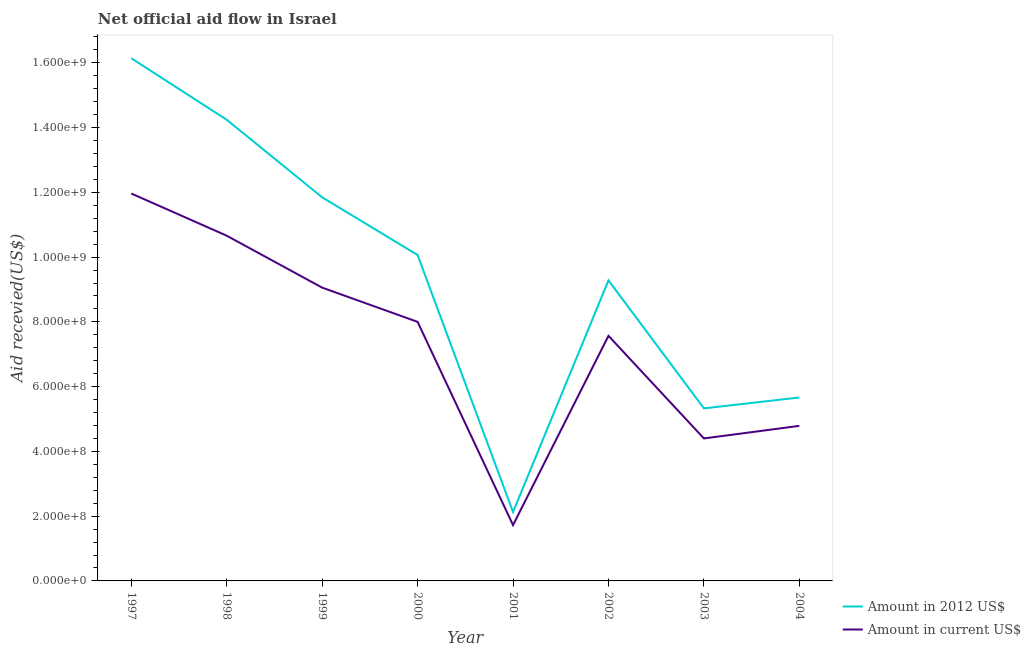Is the number of lines equal to the number of legend labels?
Make the answer very short. Yes. What is the amount of aid received(expressed in 2012 us$) in 1997?
Your answer should be compact. 1.61e+09. Across all years, what is the maximum amount of aid received(expressed in 2012 us$)?
Keep it short and to the point. 1.61e+09. Across all years, what is the minimum amount of aid received(expressed in us$)?
Keep it short and to the point. 1.72e+08. In which year was the amount of aid received(expressed in us$) minimum?
Provide a succinct answer. 2001. What is the total amount of aid received(expressed in 2012 us$) in the graph?
Your response must be concise. 7.47e+09. What is the difference between the amount of aid received(expressed in us$) in 1999 and that in 2002?
Offer a terse response. 1.49e+08. What is the difference between the amount of aid received(expressed in us$) in 2003 and the amount of aid received(expressed in 2012 us$) in 2000?
Offer a terse response. -5.66e+08. What is the average amount of aid received(expressed in 2012 us$) per year?
Offer a very short reply. 9.34e+08. In the year 2004, what is the difference between the amount of aid received(expressed in 2012 us$) and amount of aid received(expressed in us$)?
Provide a short and direct response. 8.76e+07. What is the ratio of the amount of aid received(expressed in us$) in 2001 to that in 2002?
Keep it short and to the point. 0.23. Is the amount of aid received(expressed in us$) in 2001 less than that in 2004?
Offer a terse response. Yes. Is the difference between the amount of aid received(expressed in 2012 us$) in 1998 and 2003 greater than the difference between the amount of aid received(expressed in us$) in 1998 and 2003?
Provide a short and direct response. Yes. What is the difference between the highest and the second highest amount of aid received(expressed in 2012 us$)?
Provide a succinct answer. 1.90e+08. What is the difference between the highest and the lowest amount of aid received(expressed in 2012 us$)?
Provide a succinct answer. 1.40e+09. Is the sum of the amount of aid received(expressed in 2012 us$) in 2001 and 2004 greater than the maximum amount of aid received(expressed in us$) across all years?
Provide a short and direct response. No. Is the amount of aid received(expressed in 2012 us$) strictly less than the amount of aid received(expressed in us$) over the years?
Provide a short and direct response. No. How many lines are there?
Keep it short and to the point. 2. How many years are there in the graph?
Keep it short and to the point. 8. What is the difference between two consecutive major ticks on the Y-axis?
Your answer should be compact. 2.00e+08. Are the values on the major ticks of Y-axis written in scientific E-notation?
Offer a very short reply. Yes. Does the graph contain any zero values?
Make the answer very short. No. Does the graph contain grids?
Your answer should be very brief. No. How many legend labels are there?
Give a very brief answer. 2. What is the title of the graph?
Ensure brevity in your answer.  Net official aid flow in Israel. What is the label or title of the X-axis?
Your answer should be very brief. Year. What is the label or title of the Y-axis?
Your answer should be very brief. Aid recevied(US$). What is the Aid recevied(US$) in Amount in 2012 US$ in 1997?
Your answer should be compact. 1.61e+09. What is the Aid recevied(US$) in Amount in current US$ in 1997?
Keep it short and to the point. 1.20e+09. What is the Aid recevied(US$) of Amount in 2012 US$ in 1998?
Provide a short and direct response. 1.42e+09. What is the Aid recevied(US$) of Amount in current US$ in 1998?
Ensure brevity in your answer.  1.07e+09. What is the Aid recevied(US$) of Amount in 2012 US$ in 1999?
Make the answer very short. 1.18e+09. What is the Aid recevied(US$) in Amount in current US$ in 1999?
Your answer should be compact. 9.06e+08. What is the Aid recevied(US$) in Amount in 2012 US$ in 2000?
Offer a terse response. 1.01e+09. What is the Aid recevied(US$) in Amount in current US$ in 2000?
Provide a succinct answer. 8.00e+08. What is the Aid recevied(US$) in Amount in 2012 US$ in 2001?
Provide a succinct answer. 2.13e+08. What is the Aid recevied(US$) in Amount in current US$ in 2001?
Provide a short and direct response. 1.72e+08. What is the Aid recevied(US$) in Amount in 2012 US$ in 2002?
Ensure brevity in your answer.  9.28e+08. What is the Aid recevied(US$) of Amount in current US$ in 2002?
Keep it short and to the point. 7.57e+08. What is the Aid recevied(US$) in Amount in 2012 US$ in 2003?
Offer a terse response. 5.33e+08. What is the Aid recevied(US$) of Amount in current US$ in 2003?
Offer a terse response. 4.40e+08. What is the Aid recevied(US$) in Amount in 2012 US$ in 2004?
Provide a short and direct response. 5.66e+08. What is the Aid recevied(US$) in Amount in current US$ in 2004?
Your answer should be very brief. 4.79e+08. Across all years, what is the maximum Aid recevied(US$) of Amount in 2012 US$?
Your response must be concise. 1.61e+09. Across all years, what is the maximum Aid recevied(US$) of Amount in current US$?
Offer a very short reply. 1.20e+09. Across all years, what is the minimum Aid recevied(US$) of Amount in 2012 US$?
Provide a succinct answer. 2.13e+08. Across all years, what is the minimum Aid recevied(US$) in Amount in current US$?
Your answer should be very brief. 1.72e+08. What is the total Aid recevied(US$) in Amount in 2012 US$ in the graph?
Your answer should be very brief. 7.47e+09. What is the total Aid recevied(US$) of Amount in current US$ in the graph?
Your answer should be very brief. 5.82e+09. What is the difference between the Aid recevied(US$) of Amount in 2012 US$ in 1997 and that in 1998?
Your answer should be very brief. 1.90e+08. What is the difference between the Aid recevied(US$) of Amount in current US$ in 1997 and that in 1998?
Your answer should be very brief. 1.30e+08. What is the difference between the Aid recevied(US$) in Amount in 2012 US$ in 1997 and that in 1999?
Your answer should be compact. 4.29e+08. What is the difference between the Aid recevied(US$) in Amount in current US$ in 1997 and that in 1999?
Your response must be concise. 2.91e+08. What is the difference between the Aid recevied(US$) of Amount in 2012 US$ in 1997 and that in 2000?
Your answer should be very brief. 6.08e+08. What is the difference between the Aid recevied(US$) in Amount in current US$ in 1997 and that in 2000?
Your answer should be compact. 3.96e+08. What is the difference between the Aid recevied(US$) of Amount in 2012 US$ in 1997 and that in 2001?
Provide a short and direct response. 1.40e+09. What is the difference between the Aid recevied(US$) of Amount in current US$ in 1997 and that in 2001?
Keep it short and to the point. 1.02e+09. What is the difference between the Aid recevied(US$) in Amount in 2012 US$ in 1997 and that in 2002?
Make the answer very short. 6.86e+08. What is the difference between the Aid recevied(US$) of Amount in current US$ in 1997 and that in 2002?
Provide a short and direct response. 4.39e+08. What is the difference between the Aid recevied(US$) of Amount in 2012 US$ in 1997 and that in 2003?
Provide a succinct answer. 1.08e+09. What is the difference between the Aid recevied(US$) of Amount in current US$ in 1997 and that in 2003?
Your response must be concise. 7.56e+08. What is the difference between the Aid recevied(US$) of Amount in 2012 US$ in 1997 and that in 2004?
Give a very brief answer. 1.05e+09. What is the difference between the Aid recevied(US$) in Amount in current US$ in 1997 and that in 2004?
Offer a very short reply. 7.18e+08. What is the difference between the Aid recevied(US$) in Amount in 2012 US$ in 1998 and that in 1999?
Provide a succinct answer. 2.39e+08. What is the difference between the Aid recevied(US$) of Amount in current US$ in 1998 and that in 1999?
Provide a short and direct response. 1.60e+08. What is the difference between the Aid recevied(US$) of Amount in 2012 US$ in 1998 and that in 2000?
Your response must be concise. 4.18e+08. What is the difference between the Aid recevied(US$) of Amount in current US$ in 1998 and that in 2000?
Ensure brevity in your answer.  2.66e+08. What is the difference between the Aid recevied(US$) in Amount in 2012 US$ in 1998 and that in 2001?
Keep it short and to the point. 1.21e+09. What is the difference between the Aid recevied(US$) in Amount in current US$ in 1998 and that in 2001?
Make the answer very short. 8.94e+08. What is the difference between the Aid recevied(US$) in Amount in 2012 US$ in 1998 and that in 2002?
Offer a terse response. 4.96e+08. What is the difference between the Aid recevied(US$) in Amount in current US$ in 1998 and that in 2002?
Your answer should be compact. 3.09e+08. What is the difference between the Aid recevied(US$) of Amount in 2012 US$ in 1998 and that in 2003?
Keep it short and to the point. 8.91e+08. What is the difference between the Aid recevied(US$) in Amount in current US$ in 1998 and that in 2003?
Offer a very short reply. 6.26e+08. What is the difference between the Aid recevied(US$) in Amount in 2012 US$ in 1998 and that in 2004?
Your response must be concise. 8.58e+08. What is the difference between the Aid recevied(US$) of Amount in current US$ in 1998 and that in 2004?
Your answer should be very brief. 5.87e+08. What is the difference between the Aid recevied(US$) of Amount in 2012 US$ in 1999 and that in 2000?
Keep it short and to the point. 1.78e+08. What is the difference between the Aid recevied(US$) in Amount in current US$ in 1999 and that in 2000?
Ensure brevity in your answer.  1.06e+08. What is the difference between the Aid recevied(US$) of Amount in 2012 US$ in 1999 and that in 2001?
Ensure brevity in your answer.  9.72e+08. What is the difference between the Aid recevied(US$) of Amount in current US$ in 1999 and that in 2001?
Provide a succinct answer. 7.33e+08. What is the difference between the Aid recevied(US$) in Amount in 2012 US$ in 1999 and that in 2002?
Provide a succinct answer. 2.57e+08. What is the difference between the Aid recevied(US$) of Amount in current US$ in 1999 and that in 2002?
Keep it short and to the point. 1.49e+08. What is the difference between the Aid recevied(US$) in Amount in 2012 US$ in 1999 and that in 2003?
Provide a succinct answer. 6.52e+08. What is the difference between the Aid recevied(US$) in Amount in current US$ in 1999 and that in 2003?
Provide a short and direct response. 4.66e+08. What is the difference between the Aid recevied(US$) in Amount in 2012 US$ in 1999 and that in 2004?
Provide a short and direct response. 6.18e+08. What is the difference between the Aid recevied(US$) of Amount in current US$ in 1999 and that in 2004?
Make the answer very short. 4.27e+08. What is the difference between the Aid recevied(US$) of Amount in 2012 US$ in 2000 and that in 2001?
Ensure brevity in your answer.  7.94e+08. What is the difference between the Aid recevied(US$) of Amount in current US$ in 2000 and that in 2001?
Offer a terse response. 6.28e+08. What is the difference between the Aid recevied(US$) of Amount in 2012 US$ in 2000 and that in 2002?
Offer a terse response. 7.83e+07. What is the difference between the Aid recevied(US$) of Amount in current US$ in 2000 and that in 2002?
Offer a very short reply. 4.31e+07. What is the difference between the Aid recevied(US$) of Amount in 2012 US$ in 2000 and that in 2003?
Give a very brief answer. 4.74e+08. What is the difference between the Aid recevied(US$) in Amount in current US$ in 2000 and that in 2003?
Provide a short and direct response. 3.60e+08. What is the difference between the Aid recevied(US$) in Amount in 2012 US$ in 2000 and that in 2004?
Offer a terse response. 4.40e+08. What is the difference between the Aid recevied(US$) of Amount in current US$ in 2000 and that in 2004?
Offer a terse response. 3.21e+08. What is the difference between the Aid recevied(US$) of Amount in 2012 US$ in 2001 and that in 2002?
Provide a short and direct response. -7.15e+08. What is the difference between the Aid recevied(US$) of Amount in current US$ in 2001 and that in 2002?
Offer a very short reply. -5.85e+08. What is the difference between the Aid recevied(US$) in Amount in 2012 US$ in 2001 and that in 2003?
Offer a very short reply. -3.20e+08. What is the difference between the Aid recevied(US$) in Amount in current US$ in 2001 and that in 2003?
Provide a short and direct response. -2.68e+08. What is the difference between the Aid recevied(US$) in Amount in 2012 US$ in 2001 and that in 2004?
Your answer should be compact. -3.54e+08. What is the difference between the Aid recevied(US$) in Amount in current US$ in 2001 and that in 2004?
Offer a terse response. -3.06e+08. What is the difference between the Aid recevied(US$) in Amount in 2012 US$ in 2002 and that in 2003?
Make the answer very short. 3.95e+08. What is the difference between the Aid recevied(US$) in Amount in current US$ in 2002 and that in 2003?
Your response must be concise. 3.17e+08. What is the difference between the Aid recevied(US$) in Amount in 2012 US$ in 2002 and that in 2004?
Keep it short and to the point. 3.62e+08. What is the difference between the Aid recevied(US$) in Amount in current US$ in 2002 and that in 2004?
Give a very brief answer. 2.78e+08. What is the difference between the Aid recevied(US$) in Amount in 2012 US$ in 2003 and that in 2004?
Make the answer very short. -3.36e+07. What is the difference between the Aid recevied(US$) in Amount in current US$ in 2003 and that in 2004?
Keep it short and to the point. -3.89e+07. What is the difference between the Aid recevied(US$) of Amount in 2012 US$ in 1997 and the Aid recevied(US$) of Amount in current US$ in 1998?
Provide a succinct answer. 5.48e+08. What is the difference between the Aid recevied(US$) of Amount in 2012 US$ in 1997 and the Aid recevied(US$) of Amount in current US$ in 1999?
Provide a succinct answer. 7.08e+08. What is the difference between the Aid recevied(US$) of Amount in 2012 US$ in 1997 and the Aid recevied(US$) of Amount in current US$ in 2000?
Provide a succinct answer. 8.14e+08. What is the difference between the Aid recevied(US$) of Amount in 2012 US$ in 1997 and the Aid recevied(US$) of Amount in current US$ in 2001?
Make the answer very short. 1.44e+09. What is the difference between the Aid recevied(US$) of Amount in 2012 US$ in 1997 and the Aid recevied(US$) of Amount in current US$ in 2002?
Your answer should be compact. 8.57e+08. What is the difference between the Aid recevied(US$) in Amount in 2012 US$ in 1997 and the Aid recevied(US$) in Amount in current US$ in 2003?
Offer a terse response. 1.17e+09. What is the difference between the Aid recevied(US$) in Amount in 2012 US$ in 1997 and the Aid recevied(US$) in Amount in current US$ in 2004?
Keep it short and to the point. 1.14e+09. What is the difference between the Aid recevied(US$) of Amount in 2012 US$ in 1998 and the Aid recevied(US$) of Amount in current US$ in 1999?
Give a very brief answer. 5.18e+08. What is the difference between the Aid recevied(US$) of Amount in 2012 US$ in 1998 and the Aid recevied(US$) of Amount in current US$ in 2000?
Offer a very short reply. 6.24e+08. What is the difference between the Aid recevied(US$) of Amount in 2012 US$ in 1998 and the Aid recevied(US$) of Amount in current US$ in 2001?
Offer a very short reply. 1.25e+09. What is the difference between the Aid recevied(US$) of Amount in 2012 US$ in 1998 and the Aid recevied(US$) of Amount in current US$ in 2002?
Provide a short and direct response. 6.67e+08. What is the difference between the Aid recevied(US$) in Amount in 2012 US$ in 1998 and the Aid recevied(US$) in Amount in current US$ in 2003?
Make the answer very short. 9.84e+08. What is the difference between the Aid recevied(US$) of Amount in 2012 US$ in 1998 and the Aid recevied(US$) of Amount in current US$ in 2004?
Keep it short and to the point. 9.45e+08. What is the difference between the Aid recevied(US$) of Amount in 2012 US$ in 1999 and the Aid recevied(US$) of Amount in current US$ in 2000?
Your response must be concise. 3.85e+08. What is the difference between the Aid recevied(US$) in Amount in 2012 US$ in 1999 and the Aid recevied(US$) in Amount in current US$ in 2001?
Your response must be concise. 1.01e+09. What is the difference between the Aid recevied(US$) of Amount in 2012 US$ in 1999 and the Aid recevied(US$) of Amount in current US$ in 2002?
Your response must be concise. 4.28e+08. What is the difference between the Aid recevied(US$) of Amount in 2012 US$ in 1999 and the Aid recevied(US$) of Amount in current US$ in 2003?
Make the answer very short. 7.45e+08. What is the difference between the Aid recevied(US$) in Amount in 2012 US$ in 1999 and the Aid recevied(US$) in Amount in current US$ in 2004?
Offer a terse response. 7.06e+08. What is the difference between the Aid recevied(US$) of Amount in 2012 US$ in 2000 and the Aid recevied(US$) of Amount in current US$ in 2001?
Your response must be concise. 8.34e+08. What is the difference between the Aid recevied(US$) in Amount in 2012 US$ in 2000 and the Aid recevied(US$) in Amount in current US$ in 2002?
Your response must be concise. 2.50e+08. What is the difference between the Aid recevied(US$) of Amount in 2012 US$ in 2000 and the Aid recevied(US$) of Amount in current US$ in 2003?
Your response must be concise. 5.66e+08. What is the difference between the Aid recevied(US$) in Amount in 2012 US$ in 2000 and the Aid recevied(US$) in Amount in current US$ in 2004?
Keep it short and to the point. 5.28e+08. What is the difference between the Aid recevied(US$) in Amount in 2012 US$ in 2001 and the Aid recevied(US$) in Amount in current US$ in 2002?
Provide a short and direct response. -5.44e+08. What is the difference between the Aid recevied(US$) in Amount in 2012 US$ in 2001 and the Aid recevied(US$) in Amount in current US$ in 2003?
Provide a succinct answer. -2.27e+08. What is the difference between the Aid recevied(US$) in Amount in 2012 US$ in 2001 and the Aid recevied(US$) in Amount in current US$ in 2004?
Give a very brief answer. -2.66e+08. What is the difference between the Aid recevied(US$) of Amount in 2012 US$ in 2002 and the Aid recevied(US$) of Amount in current US$ in 2003?
Give a very brief answer. 4.88e+08. What is the difference between the Aid recevied(US$) in Amount in 2012 US$ in 2002 and the Aid recevied(US$) in Amount in current US$ in 2004?
Ensure brevity in your answer.  4.49e+08. What is the difference between the Aid recevied(US$) of Amount in 2012 US$ in 2003 and the Aid recevied(US$) of Amount in current US$ in 2004?
Offer a terse response. 5.40e+07. What is the average Aid recevied(US$) of Amount in 2012 US$ per year?
Offer a terse response. 9.34e+08. What is the average Aid recevied(US$) in Amount in current US$ per year?
Offer a terse response. 7.27e+08. In the year 1997, what is the difference between the Aid recevied(US$) in Amount in 2012 US$ and Aid recevied(US$) in Amount in current US$?
Your answer should be very brief. 4.18e+08. In the year 1998, what is the difference between the Aid recevied(US$) of Amount in 2012 US$ and Aid recevied(US$) of Amount in current US$?
Ensure brevity in your answer.  3.58e+08. In the year 1999, what is the difference between the Aid recevied(US$) in Amount in 2012 US$ and Aid recevied(US$) in Amount in current US$?
Your answer should be very brief. 2.79e+08. In the year 2000, what is the difference between the Aid recevied(US$) of Amount in 2012 US$ and Aid recevied(US$) of Amount in current US$?
Your answer should be compact. 2.06e+08. In the year 2001, what is the difference between the Aid recevied(US$) of Amount in 2012 US$ and Aid recevied(US$) of Amount in current US$?
Your response must be concise. 4.05e+07. In the year 2002, what is the difference between the Aid recevied(US$) of Amount in 2012 US$ and Aid recevied(US$) of Amount in current US$?
Offer a very short reply. 1.71e+08. In the year 2003, what is the difference between the Aid recevied(US$) in Amount in 2012 US$ and Aid recevied(US$) in Amount in current US$?
Provide a succinct answer. 9.29e+07. In the year 2004, what is the difference between the Aid recevied(US$) in Amount in 2012 US$ and Aid recevied(US$) in Amount in current US$?
Give a very brief answer. 8.76e+07. What is the ratio of the Aid recevied(US$) in Amount in 2012 US$ in 1997 to that in 1998?
Keep it short and to the point. 1.13. What is the ratio of the Aid recevied(US$) in Amount in current US$ in 1997 to that in 1998?
Provide a short and direct response. 1.12. What is the ratio of the Aid recevied(US$) in Amount in 2012 US$ in 1997 to that in 1999?
Offer a very short reply. 1.36. What is the ratio of the Aid recevied(US$) of Amount in current US$ in 1997 to that in 1999?
Offer a terse response. 1.32. What is the ratio of the Aid recevied(US$) in Amount in 2012 US$ in 1997 to that in 2000?
Give a very brief answer. 1.6. What is the ratio of the Aid recevied(US$) in Amount in current US$ in 1997 to that in 2000?
Offer a terse response. 1.5. What is the ratio of the Aid recevied(US$) of Amount in 2012 US$ in 1997 to that in 2001?
Give a very brief answer. 7.58. What is the ratio of the Aid recevied(US$) in Amount in current US$ in 1997 to that in 2001?
Provide a short and direct response. 6.94. What is the ratio of the Aid recevied(US$) of Amount in 2012 US$ in 1997 to that in 2002?
Ensure brevity in your answer.  1.74. What is the ratio of the Aid recevied(US$) of Amount in current US$ in 1997 to that in 2002?
Keep it short and to the point. 1.58. What is the ratio of the Aid recevied(US$) of Amount in 2012 US$ in 1997 to that in 2003?
Offer a terse response. 3.03. What is the ratio of the Aid recevied(US$) of Amount in current US$ in 1997 to that in 2003?
Ensure brevity in your answer.  2.72. What is the ratio of the Aid recevied(US$) of Amount in 2012 US$ in 1997 to that in 2004?
Ensure brevity in your answer.  2.85. What is the ratio of the Aid recevied(US$) of Amount in current US$ in 1997 to that in 2004?
Your answer should be very brief. 2.5. What is the ratio of the Aid recevied(US$) of Amount in 2012 US$ in 1998 to that in 1999?
Offer a terse response. 1.2. What is the ratio of the Aid recevied(US$) in Amount in current US$ in 1998 to that in 1999?
Ensure brevity in your answer.  1.18. What is the ratio of the Aid recevied(US$) in Amount in 2012 US$ in 1998 to that in 2000?
Your answer should be very brief. 1.42. What is the ratio of the Aid recevied(US$) of Amount in current US$ in 1998 to that in 2000?
Make the answer very short. 1.33. What is the ratio of the Aid recevied(US$) of Amount in 2012 US$ in 1998 to that in 2001?
Offer a terse response. 6.69. What is the ratio of the Aid recevied(US$) in Amount in current US$ in 1998 to that in 2001?
Keep it short and to the point. 6.19. What is the ratio of the Aid recevied(US$) of Amount in 2012 US$ in 1998 to that in 2002?
Give a very brief answer. 1.53. What is the ratio of the Aid recevied(US$) in Amount in current US$ in 1998 to that in 2002?
Make the answer very short. 1.41. What is the ratio of the Aid recevied(US$) of Amount in 2012 US$ in 1998 to that in 2003?
Give a very brief answer. 2.67. What is the ratio of the Aid recevied(US$) in Amount in current US$ in 1998 to that in 2003?
Your response must be concise. 2.42. What is the ratio of the Aid recevied(US$) of Amount in 2012 US$ in 1998 to that in 2004?
Provide a short and direct response. 2.51. What is the ratio of the Aid recevied(US$) in Amount in current US$ in 1998 to that in 2004?
Provide a short and direct response. 2.23. What is the ratio of the Aid recevied(US$) in Amount in 2012 US$ in 1999 to that in 2000?
Give a very brief answer. 1.18. What is the ratio of the Aid recevied(US$) in Amount in current US$ in 1999 to that in 2000?
Make the answer very short. 1.13. What is the ratio of the Aid recevied(US$) of Amount in 2012 US$ in 1999 to that in 2001?
Ensure brevity in your answer.  5.57. What is the ratio of the Aid recevied(US$) of Amount in current US$ in 1999 to that in 2001?
Provide a short and direct response. 5.26. What is the ratio of the Aid recevied(US$) in Amount in 2012 US$ in 1999 to that in 2002?
Your answer should be very brief. 1.28. What is the ratio of the Aid recevied(US$) in Amount in current US$ in 1999 to that in 2002?
Keep it short and to the point. 1.2. What is the ratio of the Aid recevied(US$) in Amount in 2012 US$ in 1999 to that in 2003?
Your response must be concise. 2.22. What is the ratio of the Aid recevied(US$) of Amount in current US$ in 1999 to that in 2003?
Ensure brevity in your answer.  2.06. What is the ratio of the Aid recevied(US$) in Amount in 2012 US$ in 1999 to that in 2004?
Give a very brief answer. 2.09. What is the ratio of the Aid recevied(US$) of Amount in current US$ in 1999 to that in 2004?
Offer a terse response. 1.89. What is the ratio of the Aid recevied(US$) in Amount in 2012 US$ in 2000 to that in 2001?
Provide a short and direct response. 4.73. What is the ratio of the Aid recevied(US$) in Amount in current US$ in 2000 to that in 2001?
Offer a terse response. 4.64. What is the ratio of the Aid recevied(US$) of Amount in 2012 US$ in 2000 to that in 2002?
Give a very brief answer. 1.08. What is the ratio of the Aid recevied(US$) of Amount in current US$ in 2000 to that in 2002?
Your answer should be very brief. 1.06. What is the ratio of the Aid recevied(US$) of Amount in 2012 US$ in 2000 to that in 2003?
Provide a short and direct response. 1.89. What is the ratio of the Aid recevied(US$) in Amount in current US$ in 2000 to that in 2003?
Offer a very short reply. 1.82. What is the ratio of the Aid recevied(US$) in Amount in 2012 US$ in 2000 to that in 2004?
Keep it short and to the point. 1.78. What is the ratio of the Aid recevied(US$) in Amount in current US$ in 2000 to that in 2004?
Make the answer very short. 1.67. What is the ratio of the Aid recevied(US$) of Amount in 2012 US$ in 2001 to that in 2002?
Offer a terse response. 0.23. What is the ratio of the Aid recevied(US$) in Amount in current US$ in 2001 to that in 2002?
Make the answer very short. 0.23. What is the ratio of the Aid recevied(US$) in Amount in 2012 US$ in 2001 to that in 2003?
Your answer should be very brief. 0.4. What is the ratio of the Aid recevied(US$) in Amount in current US$ in 2001 to that in 2003?
Ensure brevity in your answer.  0.39. What is the ratio of the Aid recevied(US$) in Amount in 2012 US$ in 2001 to that in 2004?
Your response must be concise. 0.38. What is the ratio of the Aid recevied(US$) in Amount in current US$ in 2001 to that in 2004?
Your response must be concise. 0.36. What is the ratio of the Aid recevied(US$) of Amount in 2012 US$ in 2002 to that in 2003?
Your response must be concise. 1.74. What is the ratio of the Aid recevied(US$) of Amount in current US$ in 2002 to that in 2003?
Your answer should be very brief. 1.72. What is the ratio of the Aid recevied(US$) in Amount in 2012 US$ in 2002 to that in 2004?
Keep it short and to the point. 1.64. What is the ratio of the Aid recevied(US$) of Amount in current US$ in 2002 to that in 2004?
Your answer should be very brief. 1.58. What is the ratio of the Aid recevied(US$) of Amount in 2012 US$ in 2003 to that in 2004?
Offer a very short reply. 0.94. What is the ratio of the Aid recevied(US$) of Amount in current US$ in 2003 to that in 2004?
Ensure brevity in your answer.  0.92. What is the difference between the highest and the second highest Aid recevied(US$) of Amount in 2012 US$?
Your answer should be very brief. 1.90e+08. What is the difference between the highest and the second highest Aid recevied(US$) of Amount in current US$?
Keep it short and to the point. 1.30e+08. What is the difference between the highest and the lowest Aid recevied(US$) of Amount in 2012 US$?
Keep it short and to the point. 1.40e+09. What is the difference between the highest and the lowest Aid recevied(US$) of Amount in current US$?
Offer a terse response. 1.02e+09. 